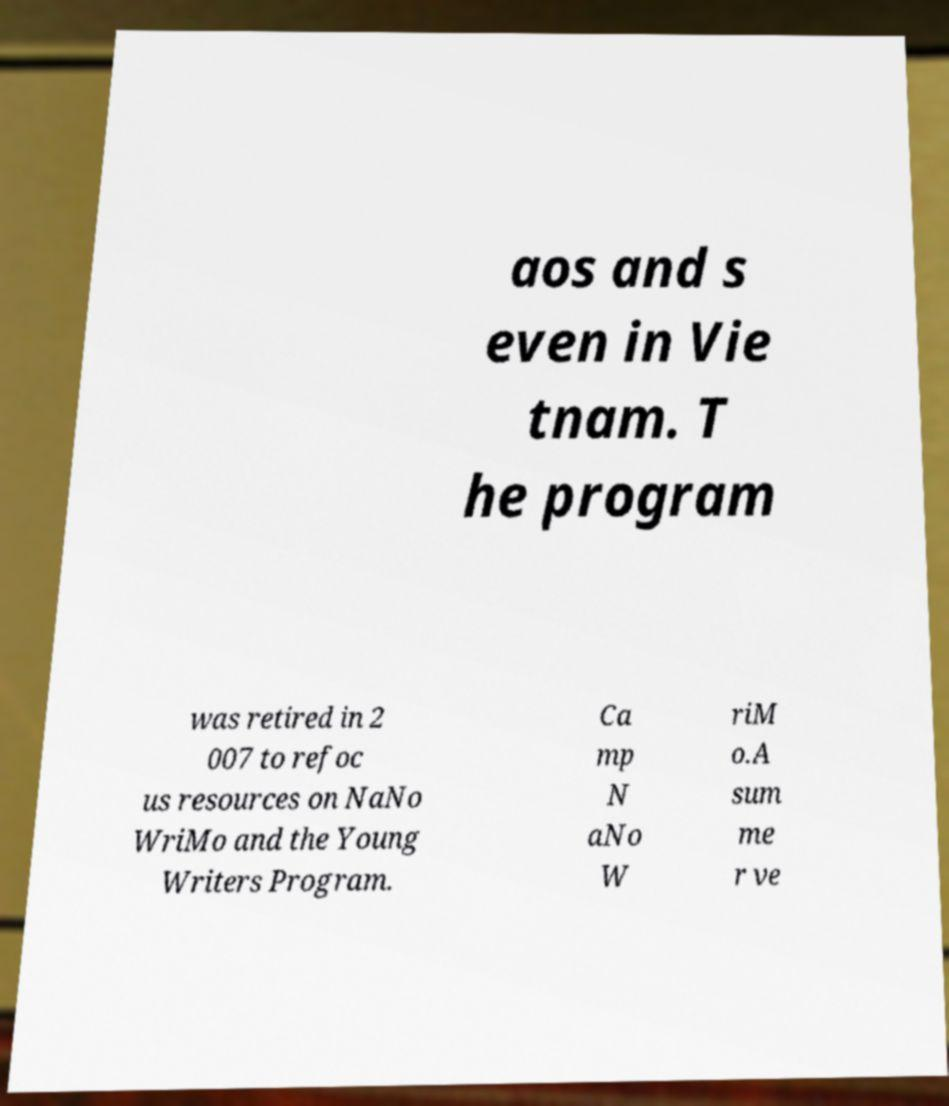Please identify and transcribe the text found in this image. aos and s even in Vie tnam. T he program was retired in 2 007 to refoc us resources on NaNo WriMo and the Young Writers Program. Ca mp N aNo W riM o.A sum me r ve 